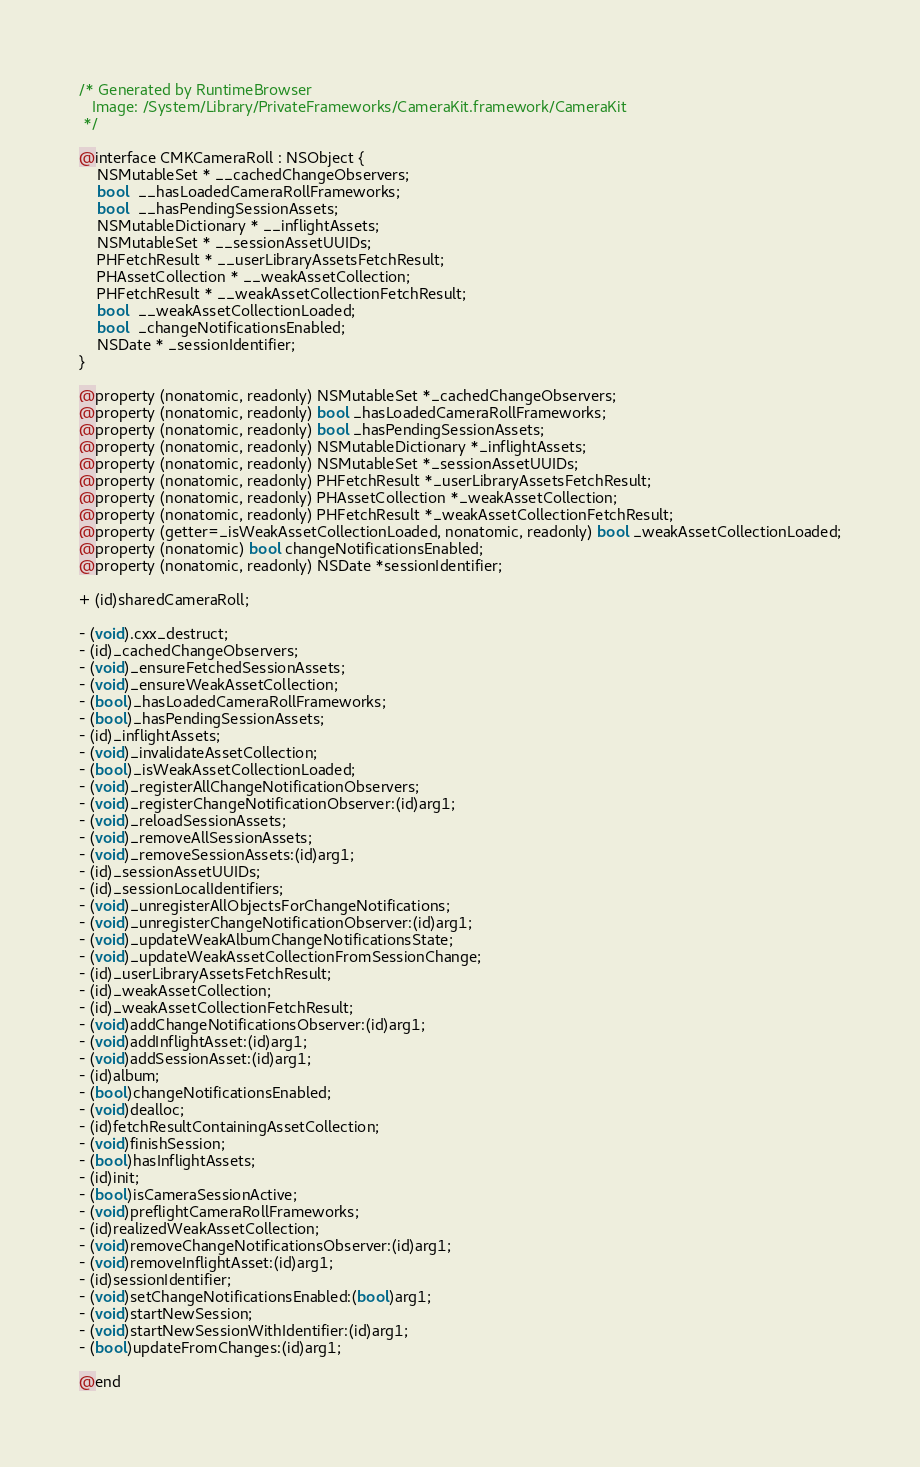Convert code to text. <code><loc_0><loc_0><loc_500><loc_500><_C_>/* Generated by RuntimeBrowser
   Image: /System/Library/PrivateFrameworks/CameraKit.framework/CameraKit
 */

@interface CMKCameraRoll : NSObject {
    NSMutableSet * __cachedChangeObservers;
    bool  __hasLoadedCameraRollFrameworks;
    bool  __hasPendingSessionAssets;
    NSMutableDictionary * __inflightAssets;
    NSMutableSet * __sessionAssetUUIDs;
    PHFetchResult * __userLibraryAssetsFetchResult;
    PHAssetCollection * __weakAssetCollection;
    PHFetchResult * __weakAssetCollectionFetchResult;
    bool  __weakAssetCollectionLoaded;
    bool  _changeNotificationsEnabled;
    NSDate * _sessionIdentifier;
}

@property (nonatomic, readonly) NSMutableSet *_cachedChangeObservers;
@property (nonatomic, readonly) bool _hasLoadedCameraRollFrameworks;
@property (nonatomic, readonly) bool _hasPendingSessionAssets;
@property (nonatomic, readonly) NSMutableDictionary *_inflightAssets;
@property (nonatomic, readonly) NSMutableSet *_sessionAssetUUIDs;
@property (nonatomic, readonly) PHFetchResult *_userLibraryAssetsFetchResult;
@property (nonatomic, readonly) PHAssetCollection *_weakAssetCollection;
@property (nonatomic, readonly) PHFetchResult *_weakAssetCollectionFetchResult;
@property (getter=_isWeakAssetCollectionLoaded, nonatomic, readonly) bool _weakAssetCollectionLoaded;
@property (nonatomic) bool changeNotificationsEnabled;
@property (nonatomic, readonly) NSDate *sessionIdentifier;

+ (id)sharedCameraRoll;

- (void).cxx_destruct;
- (id)_cachedChangeObservers;
- (void)_ensureFetchedSessionAssets;
- (void)_ensureWeakAssetCollection;
- (bool)_hasLoadedCameraRollFrameworks;
- (bool)_hasPendingSessionAssets;
- (id)_inflightAssets;
- (void)_invalidateAssetCollection;
- (bool)_isWeakAssetCollectionLoaded;
- (void)_registerAllChangeNotificationObservers;
- (void)_registerChangeNotificationObserver:(id)arg1;
- (void)_reloadSessionAssets;
- (void)_removeAllSessionAssets;
- (void)_removeSessionAssets:(id)arg1;
- (id)_sessionAssetUUIDs;
- (id)_sessionLocalIdentifiers;
- (void)_unregisterAllObjectsForChangeNotifications;
- (void)_unregisterChangeNotificationObserver:(id)arg1;
- (void)_updateWeakAlbumChangeNotificationsState;
- (void)_updateWeakAssetCollectionFromSessionChange;
- (id)_userLibraryAssetsFetchResult;
- (id)_weakAssetCollection;
- (id)_weakAssetCollectionFetchResult;
- (void)addChangeNotificationsObserver:(id)arg1;
- (void)addInflightAsset:(id)arg1;
- (void)addSessionAsset:(id)arg1;
- (id)album;
- (bool)changeNotificationsEnabled;
- (void)dealloc;
- (id)fetchResultContainingAssetCollection;
- (void)finishSession;
- (bool)hasInflightAssets;
- (id)init;
- (bool)isCameraSessionActive;
- (void)preflightCameraRollFrameworks;
- (id)realizedWeakAssetCollection;
- (void)removeChangeNotificationsObserver:(id)arg1;
- (void)removeInflightAsset:(id)arg1;
- (id)sessionIdentifier;
- (void)setChangeNotificationsEnabled:(bool)arg1;
- (void)startNewSession;
- (void)startNewSessionWithIdentifier:(id)arg1;
- (bool)updateFromChanges:(id)arg1;

@end
</code> 